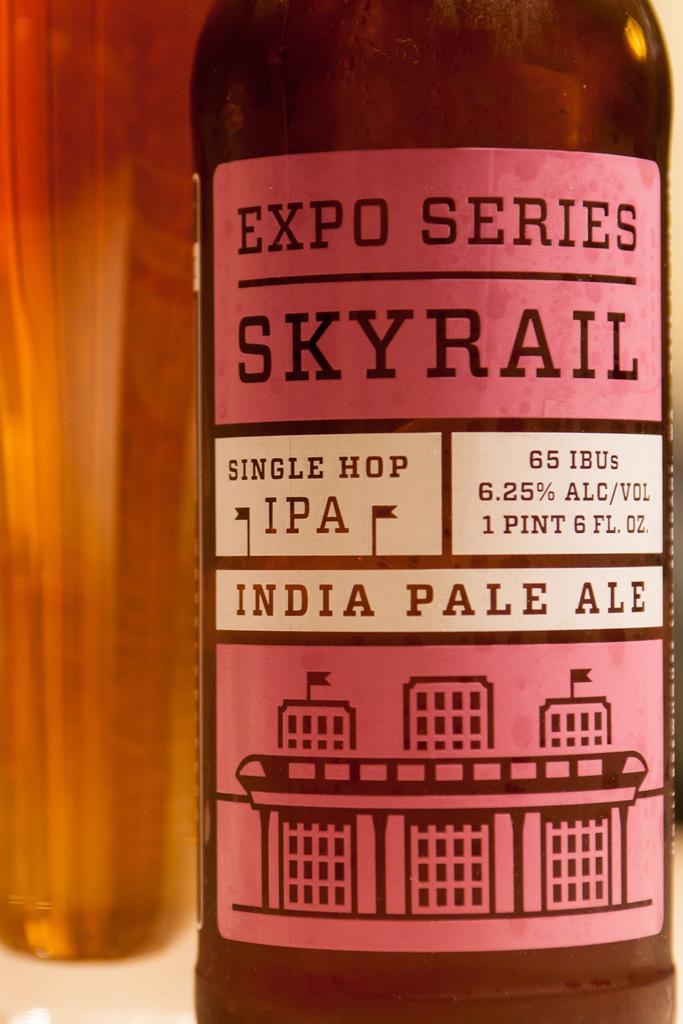What kind of ale is in the bottle?
Your response must be concise. India pale ale. 